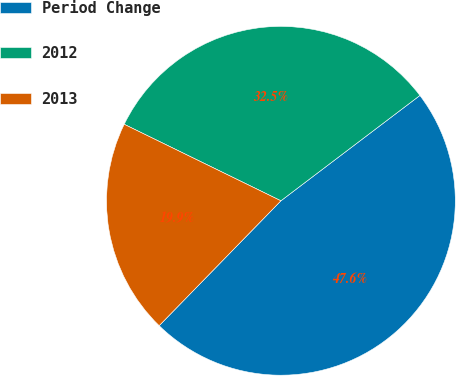<chart> <loc_0><loc_0><loc_500><loc_500><pie_chart><fcel>Period Change<fcel>2012<fcel>2013<nl><fcel>47.62%<fcel>32.45%<fcel>19.93%<nl></chart> 